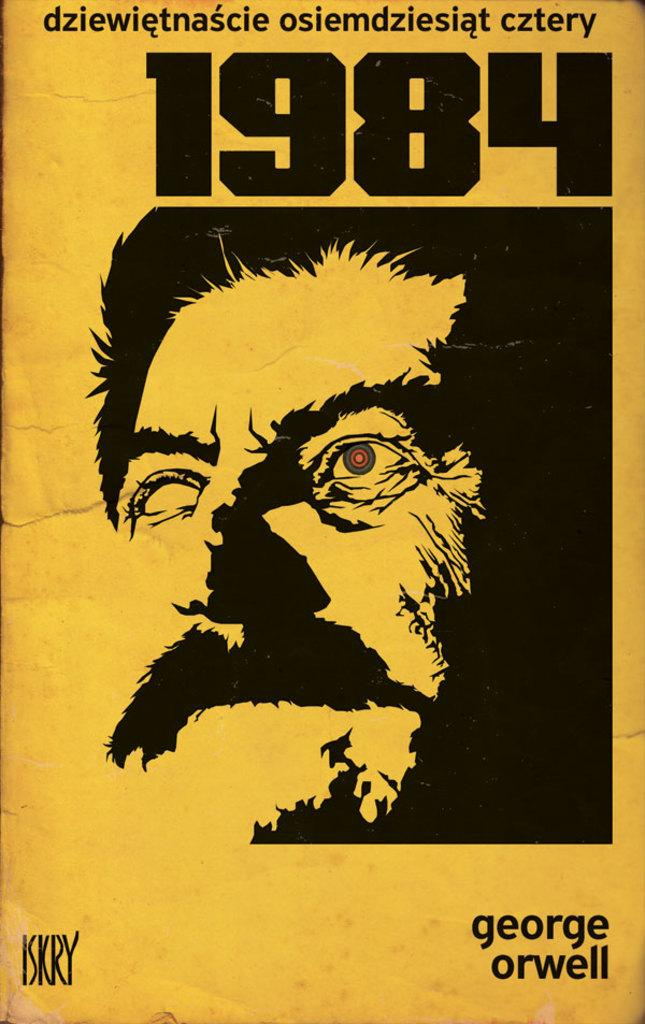<image>
Write a terse but informative summary of the picture. a 1984 advertisement that is in the color orange 